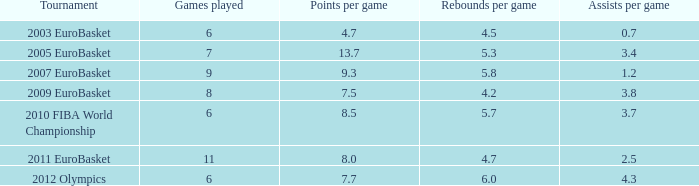How many games have a 4.7 points per game average? 6.0. 